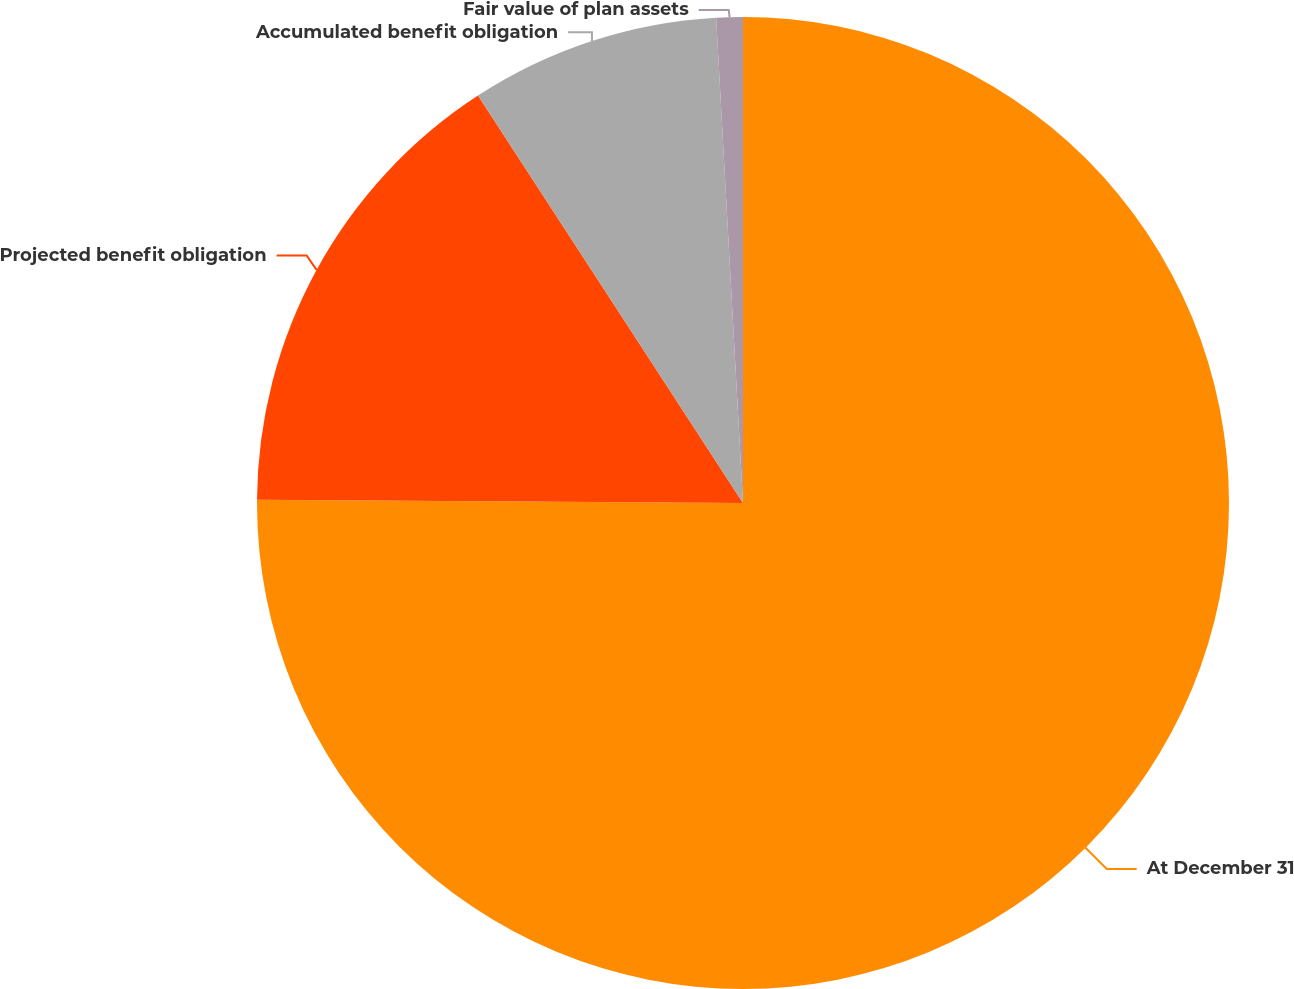Convert chart to OTSL. <chart><loc_0><loc_0><loc_500><loc_500><pie_chart><fcel>At December 31<fcel>Projected benefit obligation<fcel>Accumulated benefit obligation<fcel>Fair value of plan assets<nl><fcel>75.11%<fcel>15.72%<fcel>8.3%<fcel>0.88%<nl></chart> 